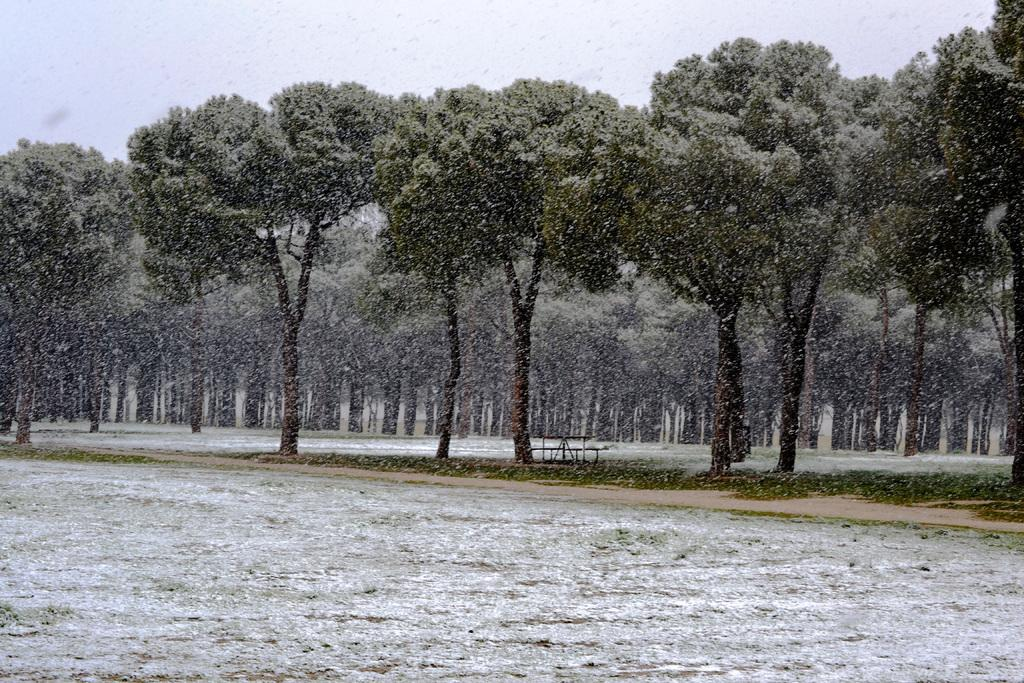What type of natural feature is at the bottom of the image? There is a river at the bottom of the image. What can be seen in the background of the image? There are trees and grass in the background of the image. Can you describe the unspecified object in the background? Unfortunately, the facts provided do not give any details about the unspecified object in the background. What is visible at the top of the image? The sky is visible at the top of the image. What type of advertisement is displayed on the government building in the image? There is no government building or advertisement present in the image. 